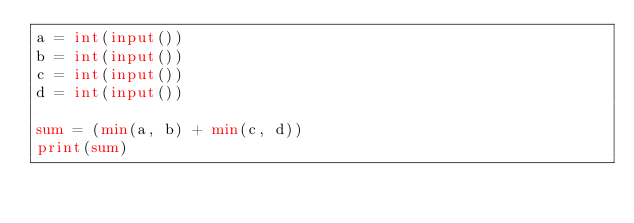<code> <loc_0><loc_0><loc_500><loc_500><_Python_>a = int(input())
b = int(input())
c = int(input())
d = int(input())

sum = (min(a, b) + min(c, d))
print(sum)</code> 